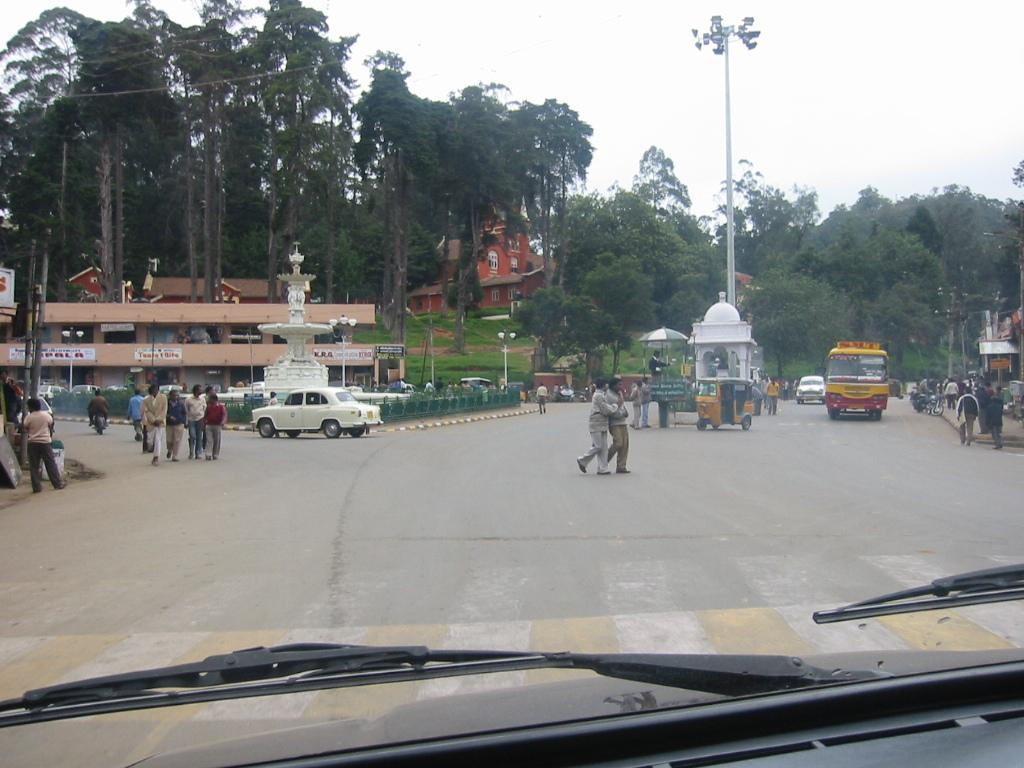What is the main feature of the image? There is a road in the image. What is happening on the road? There are vehicles on the road and people walking on the road. What can be seen in the background of the image? There are trees and a pole in the background of the image. What type of wren can be seen perched on the pole in the image? There is no wren present in the image; only vehicles, people, trees, and a pole are visible. What year is depicted in the image? The image does not depict a specific year; it is a general scene of a road with vehicles and people. 